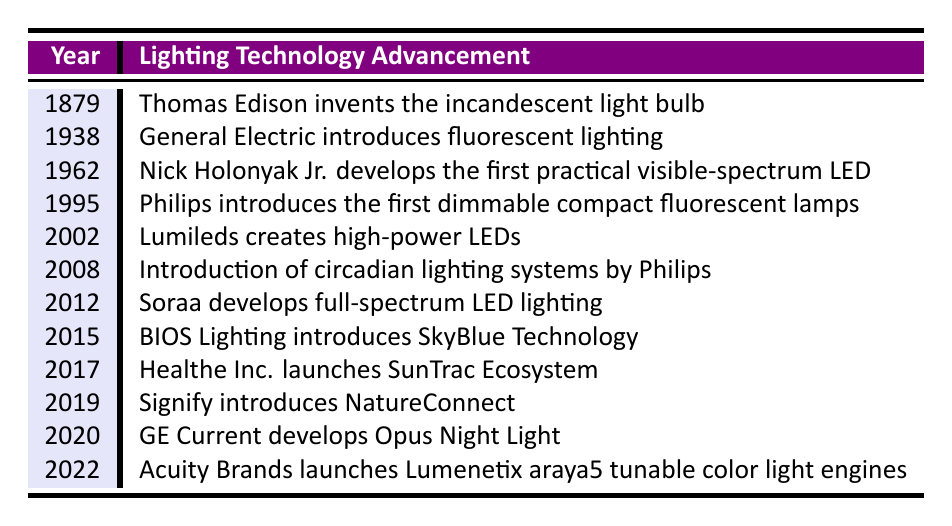What year did Thomas Edison invent the incandescent light bulb? According to the table, the year listed for Thomas Edison's invention of the incandescent light bulb is 1879.
Answer: 1879 Which company introduced fluorescent lighting in 1938? The table shows that General Electric is the company that introduced fluorescent lighting in 1938.
Answer: General Electric How many years apart were the inventions of the first practical visible-spectrum LED and the dimmable compact fluorescent lamps? The table states that the first practical visible-spectrum LED was developed in 1962 and the dimmable compact fluorescent lamps were introduced in 1995. To find the difference: 1995 - 1962 = 33 years.
Answer: 33 years Did Soraa develop full-spectrum LED lighting before or after the introduction of circadian lighting systems by Philips? According to the data, Philips introduced circadian lighting systems in 2008 and Soraa developed full-spectrum LED lighting in 2012. This means Soraa's development occurred after Philips' introduction.
Answer: After What are the advancements in lighting technology introduced between 2000 and 2020? Looking through the table, the advancements between 2000 and 2020 include Lumileds creating high-power LEDs in 2002, Philips introducing circadian lighting systems in 2008, BIOS Lighting introducing SkyBlue Technology in 2015, Signify introducing NatureConnect in 2019, and GE Current developing Opus Night Light in 2020.
Answer: 5 advancements How many advancements were introduced in the 21st century (2001 onwards)? The timeline lists events beginning from 2002 to 2022. Counting those entries: 2002, 2008, 2012, 2015, 2017, 2019, 2020, 2022 gives us a total of 8 events.
Answer: 8 events Which advancement focuses on supporting circadian rhythms in healthcare settings, and in what year was it introduced? The table indicates that BIOS Lighting introduces SkyBlue Technology, specifically designed for circadian rhythms, in 2015.
Answer: BIOS Lighting in 2015 Which two companies are responsible for introducing lighting technologies that mimic natural light patterns? According to the table, Philips introduced circadian lighting systems in 2008, and Healthe Inc. launched the SunTrac Ecosystem in 2017, both of which aim to mimic natural light patterns.
Answer: Philips and Healthe Inc 